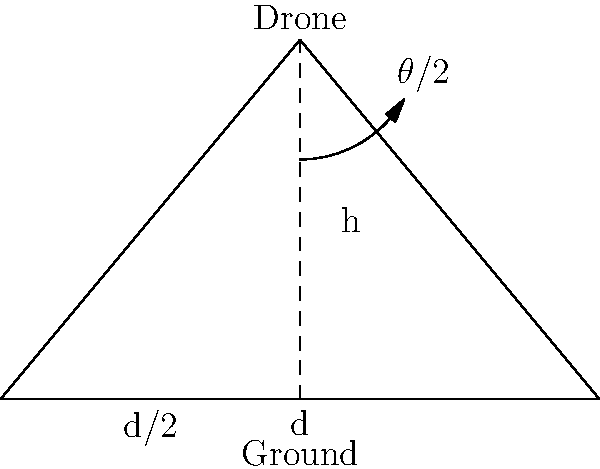A drone equipped with a camera is flying at an altitude of 100 meters. The camera has a horizontal field of view of 90°. If the camera is pointing straight down, what is the width of the area captured by the camera on the ground? To solve this problem, we need to use trigonometry. Let's break it down step by step:

1) First, we need to identify the relevant trigonometric function. In this case, we'll use the tangent function.

2) The tangent of half the field of view angle is equal to half the width of the captured area divided by the altitude:

   $\tan(\frac{\theta}{2}) = \frac{d/2}{h}$

   Where:
   $\theta$ = field of view angle (90°)
   $d$ = width of the captured area
   $h$ = altitude of the drone (100 m)

3) We know $\theta = 90°$, so $\frac{\theta}{2} = 45°$

4) Plugging in the values:

   $\tan(45°) = \frac{d/2}{100}$

5) We know that $\tan(45°) = 1$, so:

   $1 = \frac{d/2}{100}$

6) Solving for $d$:

   $d/2 = 100$
   $d = 200$

Therefore, the width of the area captured by the camera on the ground is 200 meters.
Answer: 200 meters 